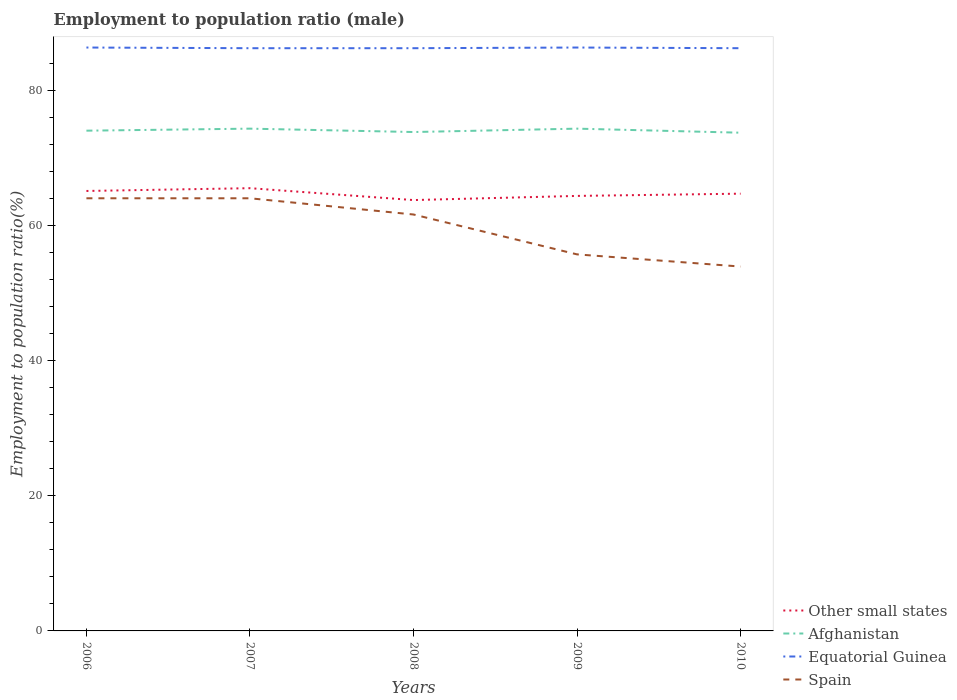How many different coloured lines are there?
Give a very brief answer. 4. Does the line corresponding to Other small states intersect with the line corresponding to Equatorial Guinea?
Offer a terse response. No. Is the number of lines equal to the number of legend labels?
Offer a very short reply. Yes. Across all years, what is the maximum employment to population ratio in Other small states?
Your response must be concise. 63.74. What is the total employment to population ratio in Equatorial Guinea in the graph?
Provide a short and direct response. 0.1. What is the difference between the highest and the second highest employment to population ratio in Equatorial Guinea?
Offer a very short reply. 0.1. What is the difference between the highest and the lowest employment to population ratio in Spain?
Provide a succinct answer. 3. What is the difference between two consecutive major ticks on the Y-axis?
Make the answer very short. 20. Where does the legend appear in the graph?
Make the answer very short. Bottom right. How many legend labels are there?
Offer a terse response. 4. What is the title of the graph?
Give a very brief answer. Employment to population ratio (male). What is the label or title of the X-axis?
Your response must be concise. Years. What is the label or title of the Y-axis?
Provide a succinct answer. Employment to population ratio(%). What is the Employment to population ratio(%) of Other small states in 2006?
Make the answer very short. 65.08. What is the Employment to population ratio(%) of Afghanistan in 2006?
Ensure brevity in your answer.  74. What is the Employment to population ratio(%) in Equatorial Guinea in 2006?
Give a very brief answer. 86.3. What is the Employment to population ratio(%) in Spain in 2006?
Provide a succinct answer. 64. What is the Employment to population ratio(%) in Other small states in 2007?
Offer a very short reply. 65.49. What is the Employment to population ratio(%) in Afghanistan in 2007?
Ensure brevity in your answer.  74.3. What is the Employment to population ratio(%) in Equatorial Guinea in 2007?
Offer a terse response. 86.2. What is the Employment to population ratio(%) in Other small states in 2008?
Ensure brevity in your answer.  63.74. What is the Employment to population ratio(%) of Afghanistan in 2008?
Offer a terse response. 73.8. What is the Employment to population ratio(%) in Equatorial Guinea in 2008?
Offer a very short reply. 86.2. What is the Employment to population ratio(%) in Spain in 2008?
Your answer should be compact. 61.6. What is the Employment to population ratio(%) in Other small states in 2009?
Ensure brevity in your answer.  64.35. What is the Employment to population ratio(%) in Afghanistan in 2009?
Provide a short and direct response. 74.3. What is the Employment to population ratio(%) of Equatorial Guinea in 2009?
Provide a succinct answer. 86.3. What is the Employment to population ratio(%) in Spain in 2009?
Offer a terse response. 55.7. What is the Employment to population ratio(%) of Other small states in 2010?
Your response must be concise. 64.68. What is the Employment to population ratio(%) of Afghanistan in 2010?
Offer a very short reply. 73.7. What is the Employment to population ratio(%) in Equatorial Guinea in 2010?
Make the answer very short. 86.2. What is the Employment to population ratio(%) of Spain in 2010?
Make the answer very short. 53.9. Across all years, what is the maximum Employment to population ratio(%) of Other small states?
Your response must be concise. 65.49. Across all years, what is the maximum Employment to population ratio(%) of Afghanistan?
Offer a very short reply. 74.3. Across all years, what is the maximum Employment to population ratio(%) in Equatorial Guinea?
Give a very brief answer. 86.3. Across all years, what is the maximum Employment to population ratio(%) in Spain?
Your answer should be compact. 64. Across all years, what is the minimum Employment to population ratio(%) in Other small states?
Your answer should be compact. 63.74. Across all years, what is the minimum Employment to population ratio(%) of Afghanistan?
Give a very brief answer. 73.7. Across all years, what is the minimum Employment to population ratio(%) of Equatorial Guinea?
Give a very brief answer. 86.2. Across all years, what is the minimum Employment to population ratio(%) of Spain?
Make the answer very short. 53.9. What is the total Employment to population ratio(%) of Other small states in the graph?
Provide a short and direct response. 323.34. What is the total Employment to population ratio(%) in Afghanistan in the graph?
Provide a short and direct response. 370.1. What is the total Employment to population ratio(%) in Equatorial Guinea in the graph?
Your answer should be very brief. 431.2. What is the total Employment to population ratio(%) in Spain in the graph?
Your response must be concise. 299.2. What is the difference between the Employment to population ratio(%) in Other small states in 2006 and that in 2007?
Your answer should be compact. -0.41. What is the difference between the Employment to population ratio(%) in Equatorial Guinea in 2006 and that in 2007?
Your answer should be very brief. 0.1. What is the difference between the Employment to population ratio(%) in Spain in 2006 and that in 2007?
Offer a very short reply. 0. What is the difference between the Employment to population ratio(%) in Other small states in 2006 and that in 2008?
Ensure brevity in your answer.  1.34. What is the difference between the Employment to population ratio(%) in Afghanistan in 2006 and that in 2008?
Offer a terse response. 0.2. What is the difference between the Employment to population ratio(%) in Equatorial Guinea in 2006 and that in 2008?
Offer a terse response. 0.1. What is the difference between the Employment to population ratio(%) of Other small states in 2006 and that in 2009?
Offer a terse response. 0.73. What is the difference between the Employment to population ratio(%) of Other small states in 2006 and that in 2010?
Your answer should be very brief. 0.4. What is the difference between the Employment to population ratio(%) of Afghanistan in 2006 and that in 2010?
Offer a terse response. 0.3. What is the difference between the Employment to population ratio(%) in Other small states in 2007 and that in 2008?
Keep it short and to the point. 1.76. What is the difference between the Employment to population ratio(%) in Afghanistan in 2007 and that in 2008?
Provide a short and direct response. 0.5. What is the difference between the Employment to population ratio(%) of Spain in 2007 and that in 2008?
Your answer should be compact. 2.4. What is the difference between the Employment to population ratio(%) of Other small states in 2007 and that in 2009?
Give a very brief answer. 1.14. What is the difference between the Employment to population ratio(%) of Equatorial Guinea in 2007 and that in 2009?
Keep it short and to the point. -0.1. What is the difference between the Employment to population ratio(%) in Other small states in 2007 and that in 2010?
Make the answer very short. 0.81. What is the difference between the Employment to population ratio(%) of Equatorial Guinea in 2007 and that in 2010?
Offer a very short reply. 0. What is the difference between the Employment to population ratio(%) of Other small states in 2008 and that in 2009?
Provide a short and direct response. -0.61. What is the difference between the Employment to population ratio(%) of Afghanistan in 2008 and that in 2009?
Provide a succinct answer. -0.5. What is the difference between the Employment to population ratio(%) in Spain in 2008 and that in 2009?
Your answer should be compact. 5.9. What is the difference between the Employment to population ratio(%) of Other small states in 2008 and that in 2010?
Your response must be concise. -0.94. What is the difference between the Employment to population ratio(%) in Equatorial Guinea in 2008 and that in 2010?
Provide a short and direct response. 0. What is the difference between the Employment to population ratio(%) of Other small states in 2009 and that in 2010?
Offer a terse response. -0.33. What is the difference between the Employment to population ratio(%) in Other small states in 2006 and the Employment to population ratio(%) in Afghanistan in 2007?
Provide a succinct answer. -9.22. What is the difference between the Employment to population ratio(%) in Other small states in 2006 and the Employment to population ratio(%) in Equatorial Guinea in 2007?
Your answer should be compact. -21.12. What is the difference between the Employment to population ratio(%) of Other small states in 2006 and the Employment to population ratio(%) of Spain in 2007?
Ensure brevity in your answer.  1.08. What is the difference between the Employment to population ratio(%) in Equatorial Guinea in 2006 and the Employment to population ratio(%) in Spain in 2007?
Make the answer very short. 22.3. What is the difference between the Employment to population ratio(%) in Other small states in 2006 and the Employment to population ratio(%) in Afghanistan in 2008?
Keep it short and to the point. -8.72. What is the difference between the Employment to population ratio(%) in Other small states in 2006 and the Employment to population ratio(%) in Equatorial Guinea in 2008?
Ensure brevity in your answer.  -21.12. What is the difference between the Employment to population ratio(%) of Other small states in 2006 and the Employment to population ratio(%) of Spain in 2008?
Your answer should be very brief. 3.48. What is the difference between the Employment to population ratio(%) in Afghanistan in 2006 and the Employment to population ratio(%) in Equatorial Guinea in 2008?
Provide a succinct answer. -12.2. What is the difference between the Employment to population ratio(%) in Afghanistan in 2006 and the Employment to population ratio(%) in Spain in 2008?
Keep it short and to the point. 12.4. What is the difference between the Employment to population ratio(%) of Equatorial Guinea in 2006 and the Employment to population ratio(%) of Spain in 2008?
Offer a very short reply. 24.7. What is the difference between the Employment to population ratio(%) in Other small states in 2006 and the Employment to population ratio(%) in Afghanistan in 2009?
Keep it short and to the point. -9.22. What is the difference between the Employment to population ratio(%) in Other small states in 2006 and the Employment to population ratio(%) in Equatorial Guinea in 2009?
Make the answer very short. -21.22. What is the difference between the Employment to population ratio(%) in Other small states in 2006 and the Employment to population ratio(%) in Spain in 2009?
Make the answer very short. 9.38. What is the difference between the Employment to population ratio(%) in Afghanistan in 2006 and the Employment to population ratio(%) in Spain in 2009?
Your response must be concise. 18.3. What is the difference between the Employment to population ratio(%) of Equatorial Guinea in 2006 and the Employment to population ratio(%) of Spain in 2009?
Provide a succinct answer. 30.6. What is the difference between the Employment to population ratio(%) of Other small states in 2006 and the Employment to population ratio(%) of Afghanistan in 2010?
Your response must be concise. -8.62. What is the difference between the Employment to population ratio(%) of Other small states in 2006 and the Employment to population ratio(%) of Equatorial Guinea in 2010?
Give a very brief answer. -21.12. What is the difference between the Employment to population ratio(%) in Other small states in 2006 and the Employment to population ratio(%) in Spain in 2010?
Your response must be concise. 11.18. What is the difference between the Employment to population ratio(%) of Afghanistan in 2006 and the Employment to population ratio(%) of Equatorial Guinea in 2010?
Ensure brevity in your answer.  -12.2. What is the difference between the Employment to population ratio(%) in Afghanistan in 2006 and the Employment to population ratio(%) in Spain in 2010?
Offer a very short reply. 20.1. What is the difference between the Employment to population ratio(%) of Equatorial Guinea in 2006 and the Employment to population ratio(%) of Spain in 2010?
Offer a terse response. 32.4. What is the difference between the Employment to population ratio(%) in Other small states in 2007 and the Employment to population ratio(%) in Afghanistan in 2008?
Provide a short and direct response. -8.31. What is the difference between the Employment to population ratio(%) of Other small states in 2007 and the Employment to population ratio(%) of Equatorial Guinea in 2008?
Keep it short and to the point. -20.71. What is the difference between the Employment to population ratio(%) in Other small states in 2007 and the Employment to population ratio(%) in Spain in 2008?
Your answer should be compact. 3.89. What is the difference between the Employment to population ratio(%) in Afghanistan in 2007 and the Employment to population ratio(%) in Equatorial Guinea in 2008?
Your response must be concise. -11.9. What is the difference between the Employment to population ratio(%) in Equatorial Guinea in 2007 and the Employment to population ratio(%) in Spain in 2008?
Your response must be concise. 24.6. What is the difference between the Employment to population ratio(%) of Other small states in 2007 and the Employment to population ratio(%) of Afghanistan in 2009?
Provide a succinct answer. -8.81. What is the difference between the Employment to population ratio(%) of Other small states in 2007 and the Employment to population ratio(%) of Equatorial Guinea in 2009?
Offer a terse response. -20.81. What is the difference between the Employment to population ratio(%) in Other small states in 2007 and the Employment to population ratio(%) in Spain in 2009?
Your answer should be very brief. 9.79. What is the difference between the Employment to population ratio(%) of Afghanistan in 2007 and the Employment to population ratio(%) of Equatorial Guinea in 2009?
Give a very brief answer. -12. What is the difference between the Employment to population ratio(%) in Afghanistan in 2007 and the Employment to population ratio(%) in Spain in 2009?
Give a very brief answer. 18.6. What is the difference between the Employment to population ratio(%) of Equatorial Guinea in 2007 and the Employment to population ratio(%) of Spain in 2009?
Your response must be concise. 30.5. What is the difference between the Employment to population ratio(%) in Other small states in 2007 and the Employment to population ratio(%) in Afghanistan in 2010?
Provide a succinct answer. -8.21. What is the difference between the Employment to population ratio(%) in Other small states in 2007 and the Employment to population ratio(%) in Equatorial Guinea in 2010?
Provide a short and direct response. -20.71. What is the difference between the Employment to population ratio(%) in Other small states in 2007 and the Employment to population ratio(%) in Spain in 2010?
Your answer should be compact. 11.59. What is the difference between the Employment to population ratio(%) in Afghanistan in 2007 and the Employment to population ratio(%) in Equatorial Guinea in 2010?
Make the answer very short. -11.9. What is the difference between the Employment to population ratio(%) in Afghanistan in 2007 and the Employment to population ratio(%) in Spain in 2010?
Make the answer very short. 20.4. What is the difference between the Employment to population ratio(%) in Equatorial Guinea in 2007 and the Employment to population ratio(%) in Spain in 2010?
Keep it short and to the point. 32.3. What is the difference between the Employment to population ratio(%) of Other small states in 2008 and the Employment to population ratio(%) of Afghanistan in 2009?
Your answer should be very brief. -10.56. What is the difference between the Employment to population ratio(%) in Other small states in 2008 and the Employment to population ratio(%) in Equatorial Guinea in 2009?
Provide a short and direct response. -22.56. What is the difference between the Employment to population ratio(%) in Other small states in 2008 and the Employment to population ratio(%) in Spain in 2009?
Give a very brief answer. 8.04. What is the difference between the Employment to population ratio(%) in Equatorial Guinea in 2008 and the Employment to population ratio(%) in Spain in 2009?
Your answer should be compact. 30.5. What is the difference between the Employment to population ratio(%) of Other small states in 2008 and the Employment to population ratio(%) of Afghanistan in 2010?
Offer a very short reply. -9.96. What is the difference between the Employment to population ratio(%) of Other small states in 2008 and the Employment to population ratio(%) of Equatorial Guinea in 2010?
Provide a short and direct response. -22.46. What is the difference between the Employment to population ratio(%) in Other small states in 2008 and the Employment to population ratio(%) in Spain in 2010?
Offer a terse response. 9.84. What is the difference between the Employment to population ratio(%) of Afghanistan in 2008 and the Employment to population ratio(%) of Equatorial Guinea in 2010?
Ensure brevity in your answer.  -12.4. What is the difference between the Employment to population ratio(%) in Equatorial Guinea in 2008 and the Employment to population ratio(%) in Spain in 2010?
Provide a short and direct response. 32.3. What is the difference between the Employment to population ratio(%) of Other small states in 2009 and the Employment to population ratio(%) of Afghanistan in 2010?
Keep it short and to the point. -9.35. What is the difference between the Employment to population ratio(%) of Other small states in 2009 and the Employment to population ratio(%) of Equatorial Guinea in 2010?
Provide a short and direct response. -21.85. What is the difference between the Employment to population ratio(%) in Other small states in 2009 and the Employment to population ratio(%) in Spain in 2010?
Provide a short and direct response. 10.45. What is the difference between the Employment to population ratio(%) in Afghanistan in 2009 and the Employment to population ratio(%) in Equatorial Guinea in 2010?
Make the answer very short. -11.9. What is the difference between the Employment to population ratio(%) in Afghanistan in 2009 and the Employment to population ratio(%) in Spain in 2010?
Make the answer very short. 20.4. What is the difference between the Employment to population ratio(%) of Equatorial Guinea in 2009 and the Employment to population ratio(%) of Spain in 2010?
Offer a terse response. 32.4. What is the average Employment to population ratio(%) of Other small states per year?
Your answer should be compact. 64.67. What is the average Employment to population ratio(%) of Afghanistan per year?
Offer a very short reply. 74.02. What is the average Employment to population ratio(%) in Equatorial Guinea per year?
Your answer should be very brief. 86.24. What is the average Employment to population ratio(%) in Spain per year?
Keep it short and to the point. 59.84. In the year 2006, what is the difference between the Employment to population ratio(%) in Other small states and Employment to population ratio(%) in Afghanistan?
Keep it short and to the point. -8.92. In the year 2006, what is the difference between the Employment to population ratio(%) in Other small states and Employment to population ratio(%) in Equatorial Guinea?
Make the answer very short. -21.22. In the year 2006, what is the difference between the Employment to population ratio(%) in Other small states and Employment to population ratio(%) in Spain?
Your answer should be very brief. 1.08. In the year 2006, what is the difference between the Employment to population ratio(%) of Afghanistan and Employment to population ratio(%) of Spain?
Your response must be concise. 10. In the year 2006, what is the difference between the Employment to population ratio(%) in Equatorial Guinea and Employment to population ratio(%) in Spain?
Provide a succinct answer. 22.3. In the year 2007, what is the difference between the Employment to population ratio(%) in Other small states and Employment to population ratio(%) in Afghanistan?
Your answer should be very brief. -8.81. In the year 2007, what is the difference between the Employment to population ratio(%) of Other small states and Employment to population ratio(%) of Equatorial Guinea?
Offer a terse response. -20.71. In the year 2007, what is the difference between the Employment to population ratio(%) of Other small states and Employment to population ratio(%) of Spain?
Offer a very short reply. 1.49. In the year 2007, what is the difference between the Employment to population ratio(%) of Afghanistan and Employment to population ratio(%) of Equatorial Guinea?
Provide a succinct answer. -11.9. In the year 2008, what is the difference between the Employment to population ratio(%) in Other small states and Employment to population ratio(%) in Afghanistan?
Offer a terse response. -10.06. In the year 2008, what is the difference between the Employment to population ratio(%) in Other small states and Employment to population ratio(%) in Equatorial Guinea?
Provide a succinct answer. -22.46. In the year 2008, what is the difference between the Employment to population ratio(%) of Other small states and Employment to population ratio(%) of Spain?
Offer a very short reply. 2.14. In the year 2008, what is the difference between the Employment to population ratio(%) in Afghanistan and Employment to population ratio(%) in Equatorial Guinea?
Ensure brevity in your answer.  -12.4. In the year 2008, what is the difference between the Employment to population ratio(%) of Afghanistan and Employment to population ratio(%) of Spain?
Offer a very short reply. 12.2. In the year 2008, what is the difference between the Employment to population ratio(%) of Equatorial Guinea and Employment to population ratio(%) of Spain?
Offer a terse response. 24.6. In the year 2009, what is the difference between the Employment to population ratio(%) of Other small states and Employment to population ratio(%) of Afghanistan?
Your response must be concise. -9.95. In the year 2009, what is the difference between the Employment to population ratio(%) in Other small states and Employment to population ratio(%) in Equatorial Guinea?
Offer a terse response. -21.95. In the year 2009, what is the difference between the Employment to population ratio(%) of Other small states and Employment to population ratio(%) of Spain?
Keep it short and to the point. 8.65. In the year 2009, what is the difference between the Employment to population ratio(%) of Afghanistan and Employment to population ratio(%) of Equatorial Guinea?
Provide a succinct answer. -12. In the year 2009, what is the difference between the Employment to population ratio(%) of Equatorial Guinea and Employment to population ratio(%) of Spain?
Your response must be concise. 30.6. In the year 2010, what is the difference between the Employment to population ratio(%) of Other small states and Employment to population ratio(%) of Afghanistan?
Give a very brief answer. -9.02. In the year 2010, what is the difference between the Employment to population ratio(%) in Other small states and Employment to population ratio(%) in Equatorial Guinea?
Provide a succinct answer. -21.52. In the year 2010, what is the difference between the Employment to population ratio(%) of Other small states and Employment to population ratio(%) of Spain?
Provide a succinct answer. 10.78. In the year 2010, what is the difference between the Employment to population ratio(%) in Afghanistan and Employment to population ratio(%) in Spain?
Keep it short and to the point. 19.8. In the year 2010, what is the difference between the Employment to population ratio(%) in Equatorial Guinea and Employment to population ratio(%) in Spain?
Your answer should be compact. 32.3. What is the ratio of the Employment to population ratio(%) in Other small states in 2006 to that in 2007?
Give a very brief answer. 0.99. What is the ratio of the Employment to population ratio(%) in Afghanistan in 2006 to that in 2007?
Your answer should be very brief. 1. What is the ratio of the Employment to population ratio(%) in Other small states in 2006 to that in 2008?
Provide a succinct answer. 1.02. What is the ratio of the Employment to population ratio(%) in Equatorial Guinea in 2006 to that in 2008?
Give a very brief answer. 1. What is the ratio of the Employment to population ratio(%) of Spain in 2006 to that in 2008?
Provide a succinct answer. 1.04. What is the ratio of the Employment to population ratio(%) of Other small states in 2006 to that in 2009?
Your answer should be very brief. 1.01. What is the ratio of the Employment to population ratio(%) of Afghanistan in 2006 to that in 2009?
Ensure brevity in your answer.  1. What is the ratio of the Employment to population ratio(%) of Equatorial Guinea in 2006 to that in 2009?
Offer a very short reply. 1. What is the ratio of the Employment to population ratio(%) in Spain in 2006 to that in 2009?
Offer a terse response. 1.15. What is the ratio of the Employment to population ratio(%) of Spain in 2006 to that in 2010?
Your response must be concise. 1.19. What is the ratio of the Employment to population ratio(%) in Other small states in 2007 to that in 2008?
Provide a succinct answer. 1.03. What is the ratio of the Employment to population ratio(%) in Afghanistan in 2007 to that in 2008?
Give a very brief answer. 1.01. What is the ratio of the Employment to population ratio(%) of Spain in 2007 to that in 2008?
Ensure brevity in your answer.  1.04. What is the ratio of the Employment to population ratio(%) in Other small states in 2007 to that in 2009?
Provide a short and direct response. 1.02. What is the ratio of the Employment to population ratio(%) in Afghanistan in 2007 to that in 2009?
Your answer should be very brief. 1. What is the ratio of the Employment to population ratio(%) of Spain in 2007 to that in 2009?
Provide a succinct answer. 1.15. What is the ratio of the Employment to population ratio(%) in Other small states in 2007 to that in 2010?
Make the answer very short. 1.01. What is the ratio of the Employment to population ratio(%) of Afghanistan in 2007 to that in 2010?
Your answer should be compact. 1.01. What is the ratio of the Employment to population ratio(%) in Equatorial Guinea in 2007 to that in 2010?
Offer a very short reply. 1. What is the ratio of the Employment to population ratio(%) in Spain in 2007 to that in 2010?
Give a very brief answer. 1.19. What is the ratio of the Employment to population ratio(%) of Other small states in 2008 to that in 2009?
Provide a succinct answer. 0.99. What is the ratio of the Employment to population ratio(%) of Spain in 2008 to that in 2009?
Give a very brief answer. 1.11. What is the ratio of the Employment to population ratio(%) in Other small states in 2008 to that in 2010?
Offer a terse response. 0.99. What is the ratio of the Employment to population ratio(%) of Afghanistan in 2008 to that in 2010?
Offer a terse response. 1. What is the ratio of the Employment to population ratio(%) of Equatorial Guinea in 2008 to that in 2010?
Offer a very short reply. 1. What is the ratio of the Employment to population ratio(%) in Spain in 2008 to that in 2010?
Offer a terse response. 1.14. What is the ratio of the Employment to population ratio(%) in Other small states in 2009 to that in 2010?
Offer a very short reply. 0.99. What is the ratio of the Employment to population ratio(%) in Afghanistan in 2009 to that in 2010?
Your response must be concise. 1.01. What is the ratio of the Employment to population ratio(%) of Spain in 2009 to that in 2010?
Offer a terse response. 1.03. What is the difference between the highest and the second highest Employment to population ratio(%) in Other small states?
Offer a very short reply. 0.41. What is the difference between the highest and the second highest Employment to population ratio(%) of Afghanistan?
Provide a succinct answer. 0. What is the difference between the highest and the lowest Employment to population ratio(%) in Other small states?
Provide a succinct answer. 1.76. 